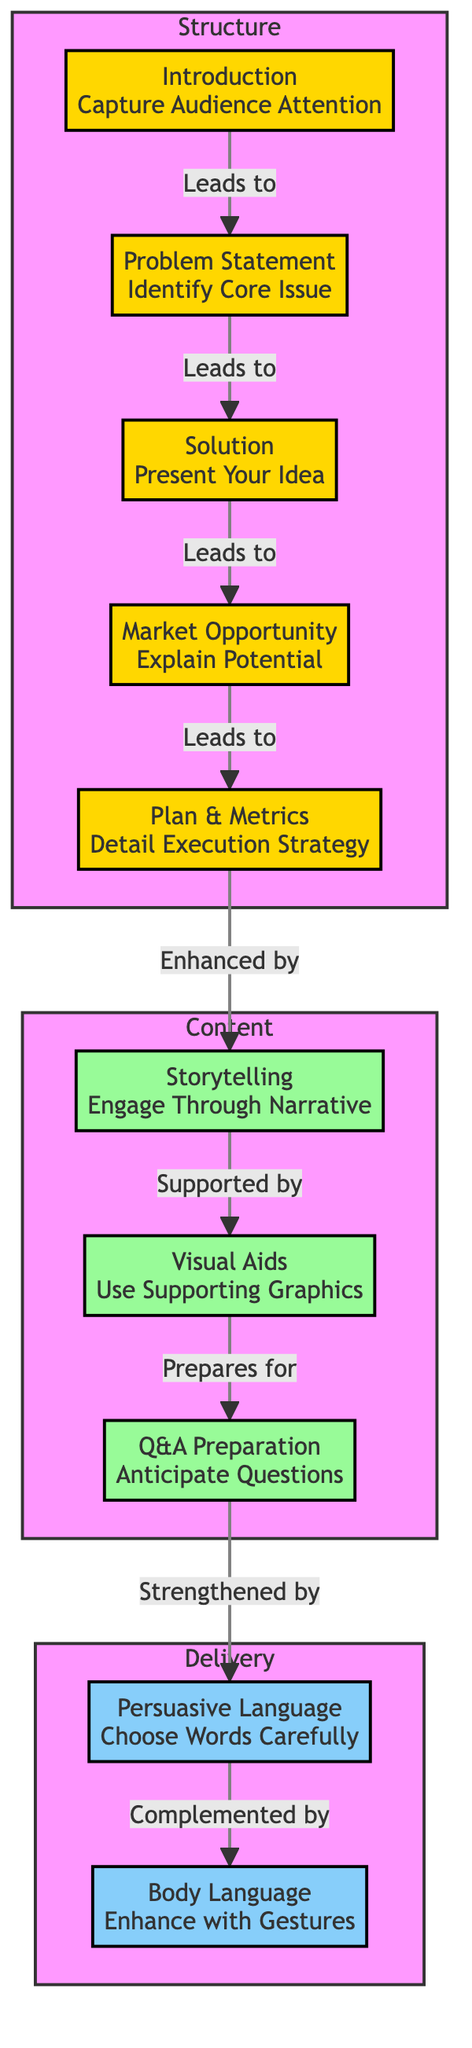What is the first step in the pitch structure? In the diagram, the first node under the "Structure" subgraph is labeled "Introduction," indicating it is the first step in the pitch structure.
Answer: Introduction How many nodes are there in the "Delivery" subgraph? By examining the diagram, there are two nodes listed under the "Delivery" subgraph: "Persuasive Language" and "Body Language." Therefore, the count is two.
Answer: 2 What leads to the "Problem Statement"? The diagram indicates that the "Introduction" node flows into the "Problem Statement" node, showing their direct relationship in the sequence of the pitch structure.
Answer: Introduction Which nodes are enhanced by "Plan & Metrics"? The "Plan & Metrics" node is enhanced by the "Storytelling" node, as indicated by the connecting edge in the diagram.
Answer: Storytelling Which delivery technique complements "Persuasive Language"? The diagram directly shows that "Body Language" is a complementary delivery technique to "Persuasive Language," as there is a connection leading from "Persuasive Language" to "Body Language."
Answer: Body Language What is the relationship between "Market Opportunity" and "Solution"? According to the flow depicted in the diagram, "Market Opportunity" follows directly after "Solution," illustrating that the solution logically leads to a discussion about the market opportunity.
Answer: Leads to What combination of nodes is recommended for effective engagement? The diagram suggests that effective engagement comes from combining "Storytelling" and "Visual Aids," as they mutually support and enhance the content of a successful pitch.
Answer: Storytelling and Visual Aids What does “Q&A Preparation” prepare for? In the diagram, "Q&A Preparation" is shown to prepare for "Persuasive Language," indicating its role in anticipating audience questions during the pitch delivery.
Answer: Persuasive Language Which component does "Problem Statement" precede? The diagram clearly indicates that "Problem Statement" is directly followed by "Solution," establishing that it comes first in this sequence.
Answer: Solution 